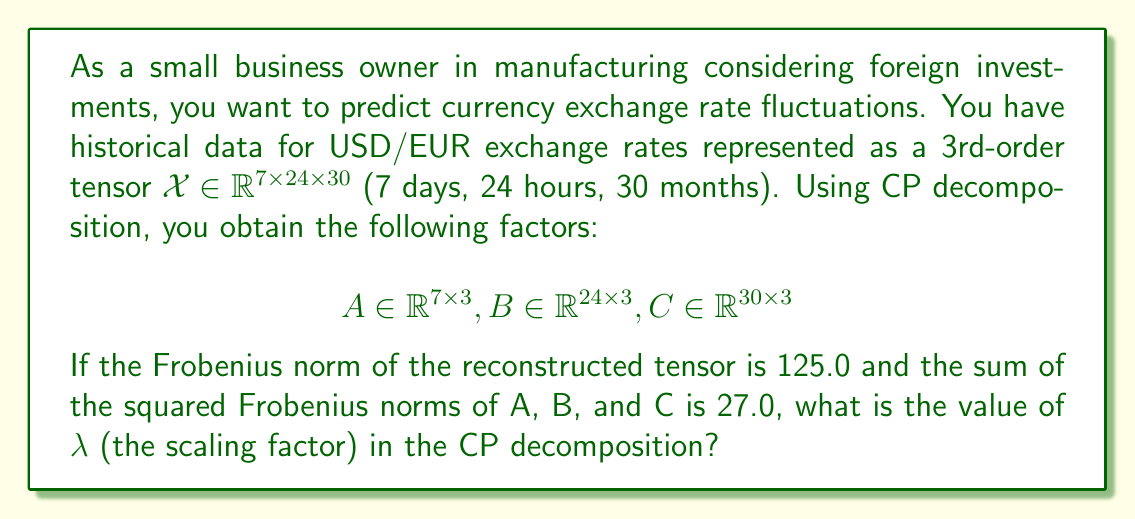Give your solution to this math problem. Let's approach this step-by-step:

1) The CP decomposition of a 3rd-order tensor $\mathcal{X}$ can be written as:

   $$\mathcal{X} \approx \sum_{r=1}^R \lambda_r a_r \circ b_r \circ c_r$$

   where $\circ$ denotes the outer product, and $R$ is the rank of the decomposition (in this case, $R=3$).

2) In matrix form, this can be written as:

   $$\mathcal{X} \approx \lambda(A \odot B \odot C)$$

   where $\odot$ is the Khatri-Rao product and $\lambda$ is a scaling factor.

3) The Frobenius norm of the reconstructed tensor is given. Let's call this $\|\mathcal{X}\|_F = 125.0$.

4) For CP decomposition, the following equality holds:

   $$\|\mathcal{X}\|_F^2 = \lambda^2(\|A\|_F^2 \|B\|_F^2 \|C\|_F^2)$$

5) We're given that the sum of the squared Frobenius norms of A, B, and C is 27.0:

   $$\|A\|_F^2 + \|B\|_F^2 + \|C\|_F^2 = 27.0$$

6) In CP decomposition, the factors are usually normalized, meaning:

   $$\|A\|_F^2 = \|B\|_F^2 = \|C\|_F^2 = 9.0$$

7) Substituting this into the equation from step 4:

   $$125.0^2 = \lambda^2(9.0 \times 9.0 \times 9.0)$$

8) Simplifying:

   $$15625 = 729\lambda^2$$

9) Solving for $\lambda$:

   $$\lambda^2 = \frac{15625}{729}$$
   $$\lambda = \sqrt{\frac{15625}{729}} \approx 4.63$$

Therefore, the value of $\lambda$ is approximately 4.63.
Answer: $\lambda \approx 4.63$ 